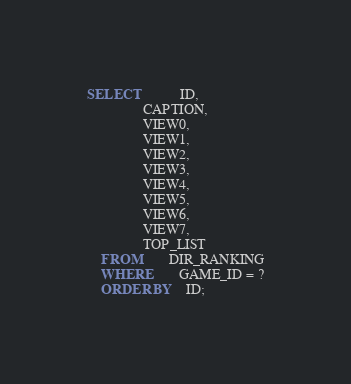Convert code to text. <code><loc_0><loc_0><loc_500><loc_500><_SQL_>SELECT			ID,
				CAPTION,
				VIEW0,
				VIEW1,
				VIEW2,
				VIEW3,
				VIEW4,
				VIEW5,
				VIEW6,
				VIEW7,
				TOP_LIST
	FROM		DIR_RANKING
	WHERE		GAME_ID = ?
	ORDER BY	ID;
</code> 